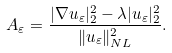<formula> <loc_0><loc_0><loc_500><loc_500>A _ { \varepsilon } = \frac { | \nabla u _ { \varepsilon } | _ { 2 } ^ { 2 } - \lambda | u _ { \varepsilon } | _ { 2 } ^ { 2 } } { \| u _ { \varepsilon } \| _ { N L } ^ { 2 } } .</formula> 